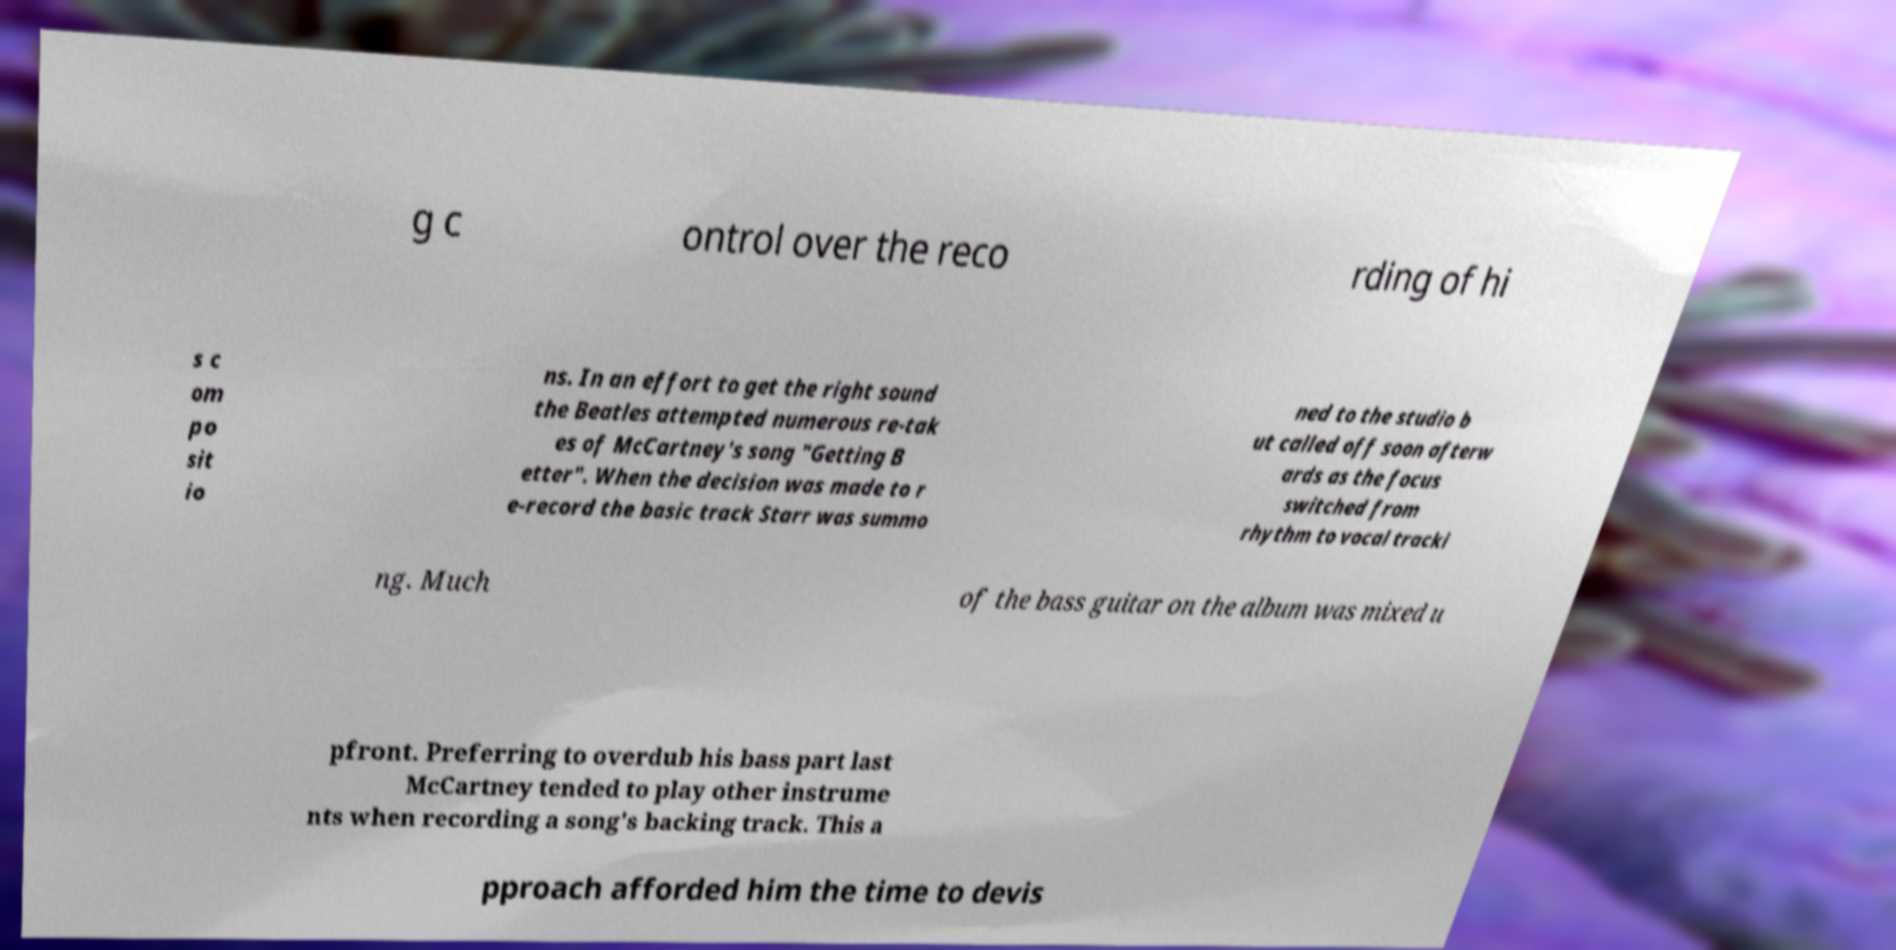Can you accurately transcribe the text from the provided image for me? g c ontrol over the reco rding of hi s c om po sit io ns. In an effort to get the right sound the Beatles attempted numerous re-tak es of McCartney's song "Getting B etter". When the decision was made to r e-record the basic track Starr was summo ned to the studio b ut called off soon afterw ards as the focus switched from rhythm to vocal tracki ng. Much of the bass guitar on the album was mixed u pfront. Preferring to overdub his bass part last McCartney tended to play other instrume nts when recording a song's backing track. This a pproach afforded him the time to devis 